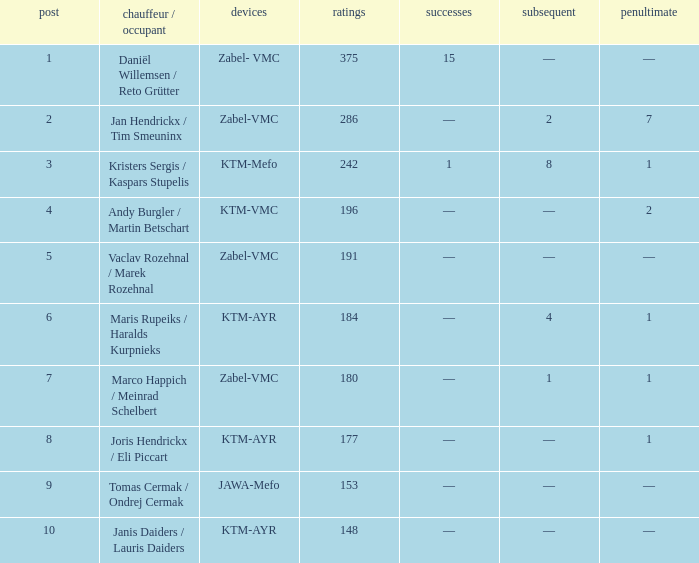Who was the chauffeur/traveler when the place was smaller than 8, the third was 1, and there was 1 triumph? Kristers Sergis / Kaspars Stupelis. 